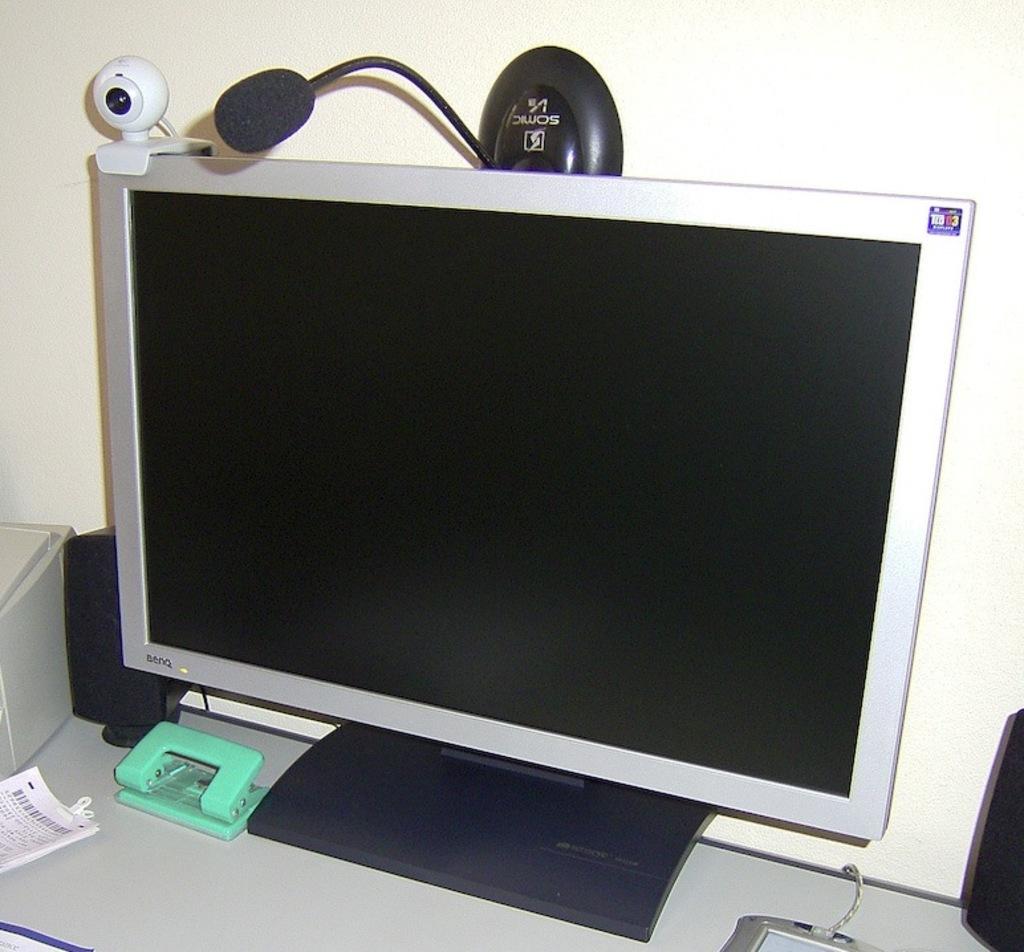What brand of computer?
Your response must be concise. Benq. 